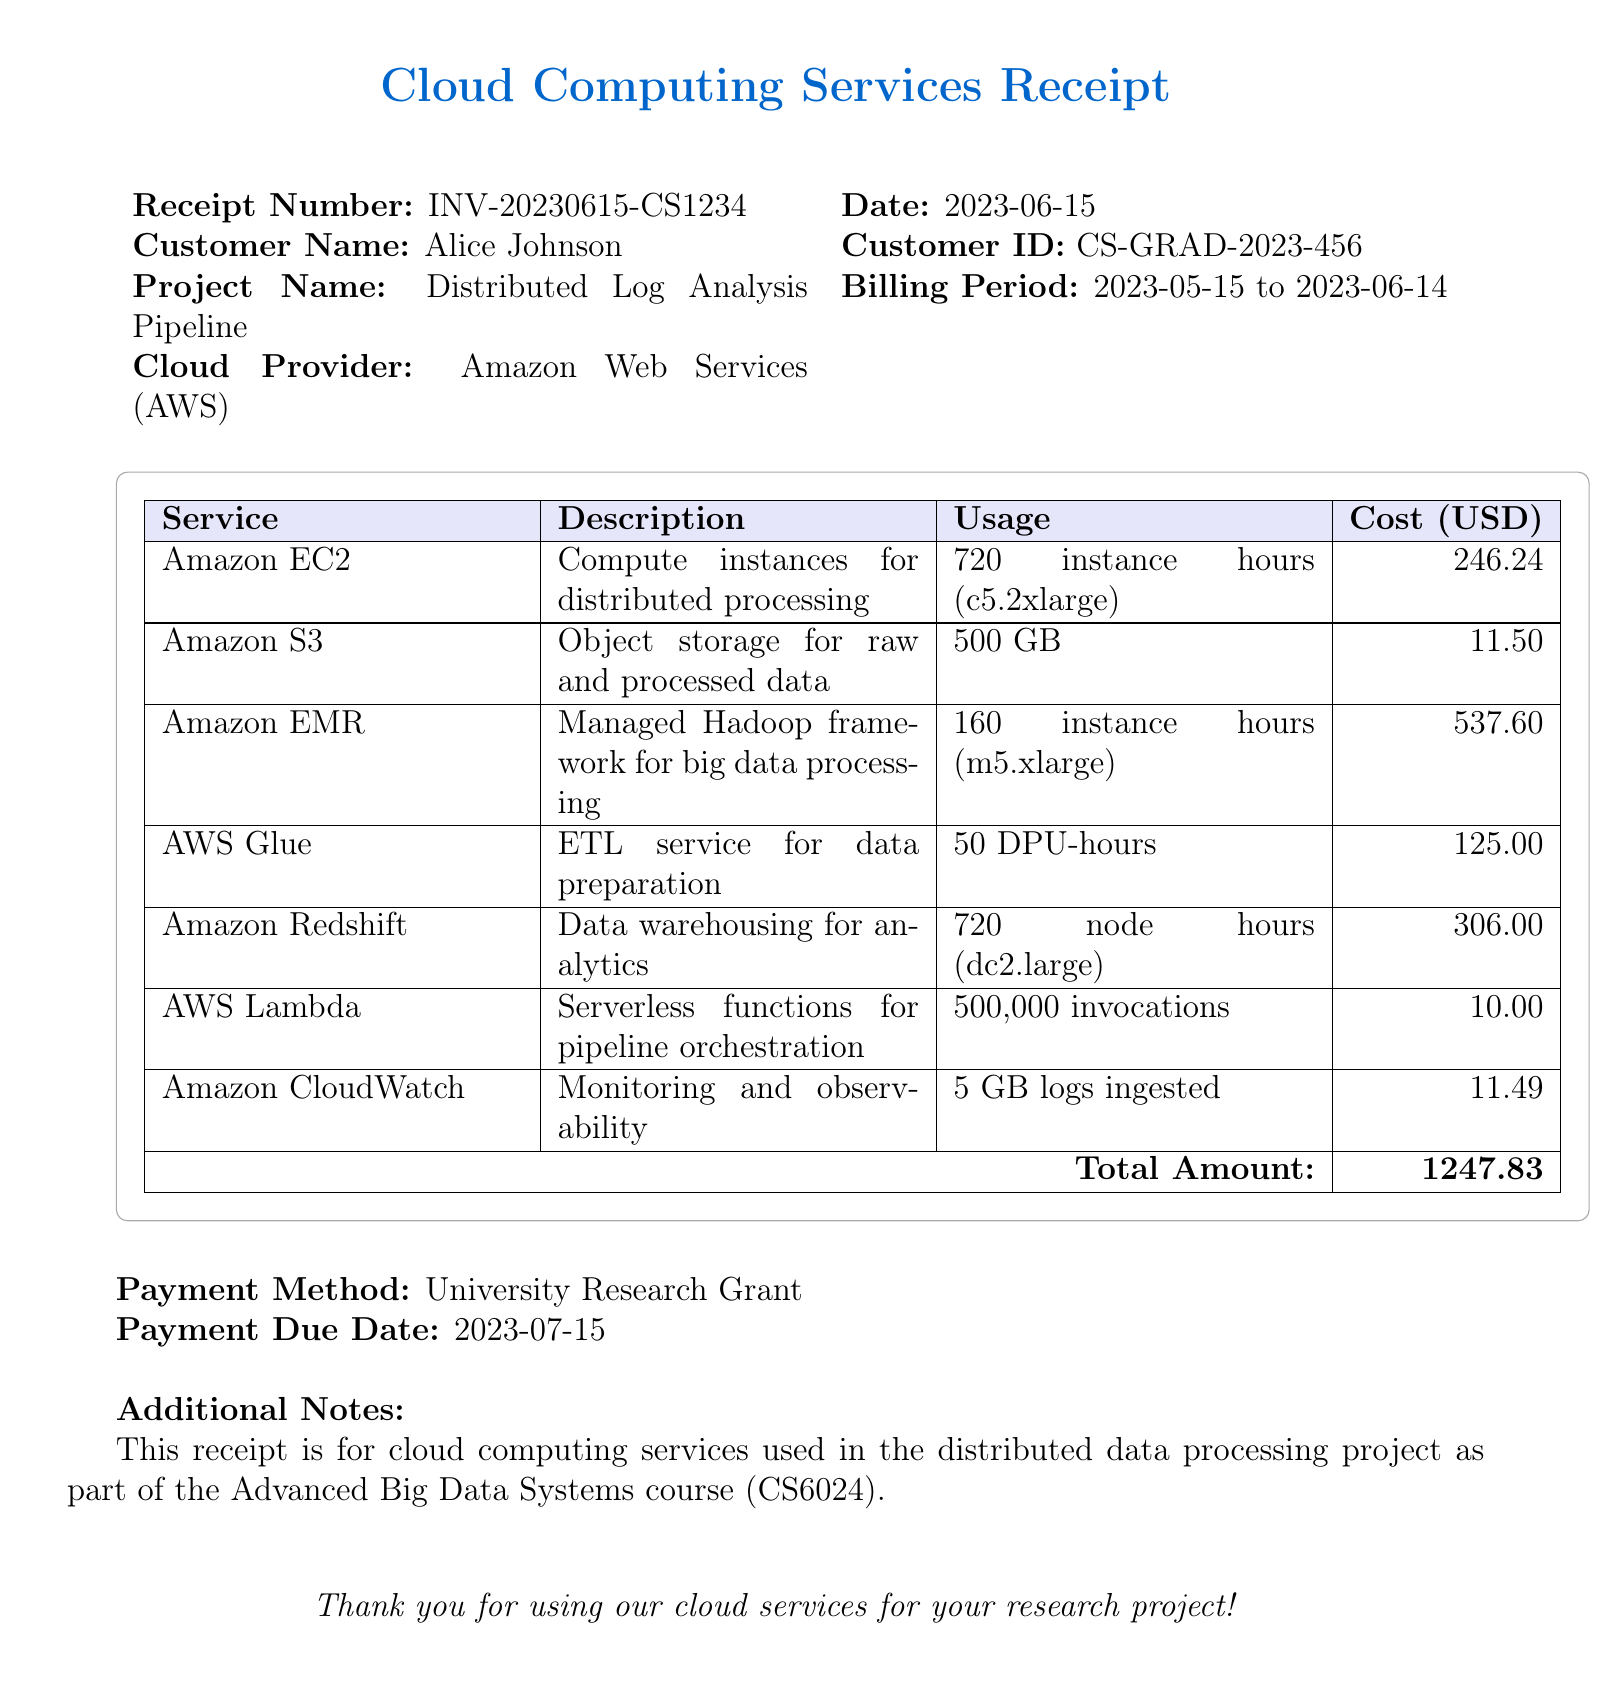What is the receipt number? The receipt number is a specific identifier for this transaction, which is listed in the document.
Answer: INV-20230615-CS1234 What is the total amount billed? The total amount billed is the sum of costs for all services used during the billing period.
Answer: 1247.83 Who is the customer? The customer is the individual who requested the services and is named in the document.
Answer: Alice Johnson What is the project name? The project name indicates the specific project for which the services were used, and it is provided in the document.
Answer: Distributed Log Analysis Pipeline How many instance hours were used for Amazon EC2? The number of instance hours used for Amazon EC2, which is specified in the service usage breakdown.
Answer: 720 instance hours Which payment method was used? The payment method denotes how the amount due was processed, as specified in the document.
Answer: University Research Grant What is the billing period of the services? The billing period defines the timeframe during which the services were utilized, noted in the document.
Answer: 2023-05-15 to 2023-06-14 How many DPU-hours were used for AWS Glue? The number of DPU-hours indicates the usage of AWS Glue, as detailed in the service breakdown.
Answer: 50 DPU-hours Which cloud provider is listed on the receipt? The cloud provider specifies the service provider for the utilized cloud computing services in the project.
Answer: Amazon Web Services (AWS) 